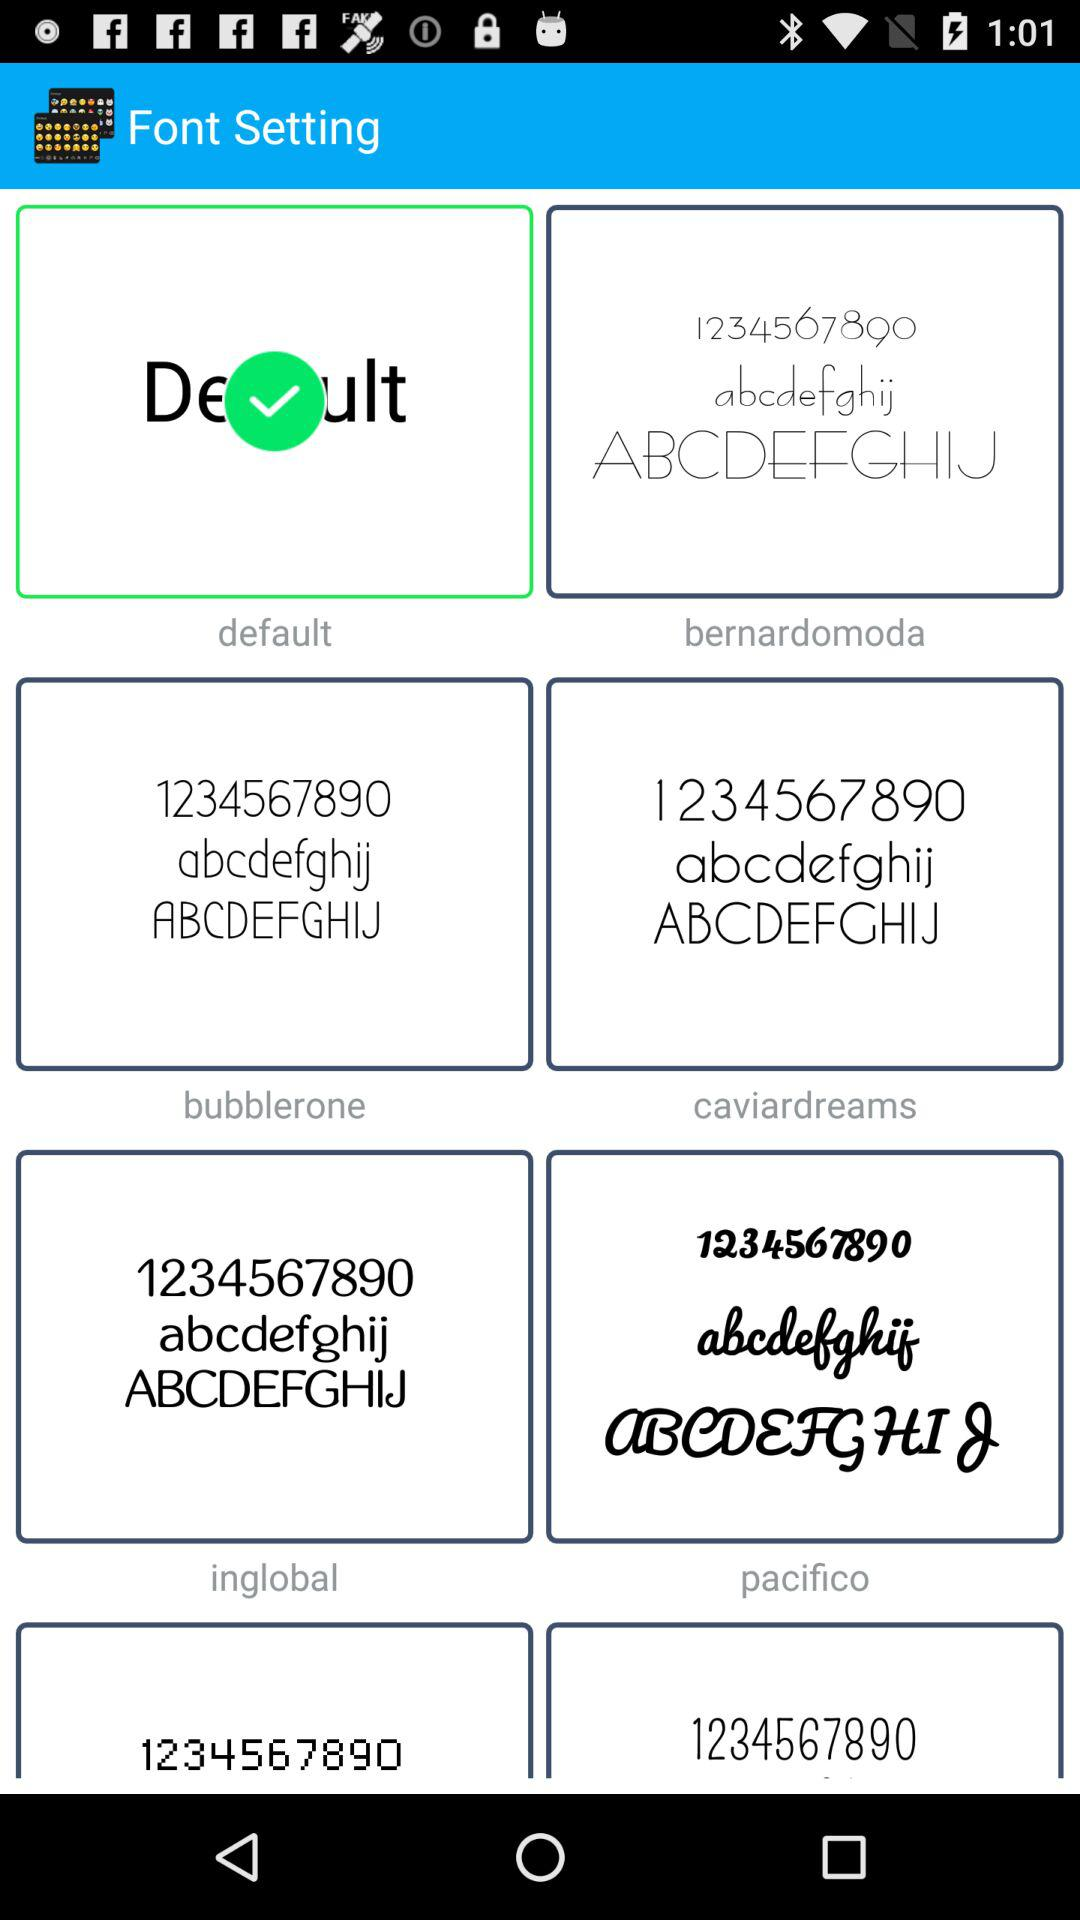What is the name of the application? The name of the application is "Font Setting". 